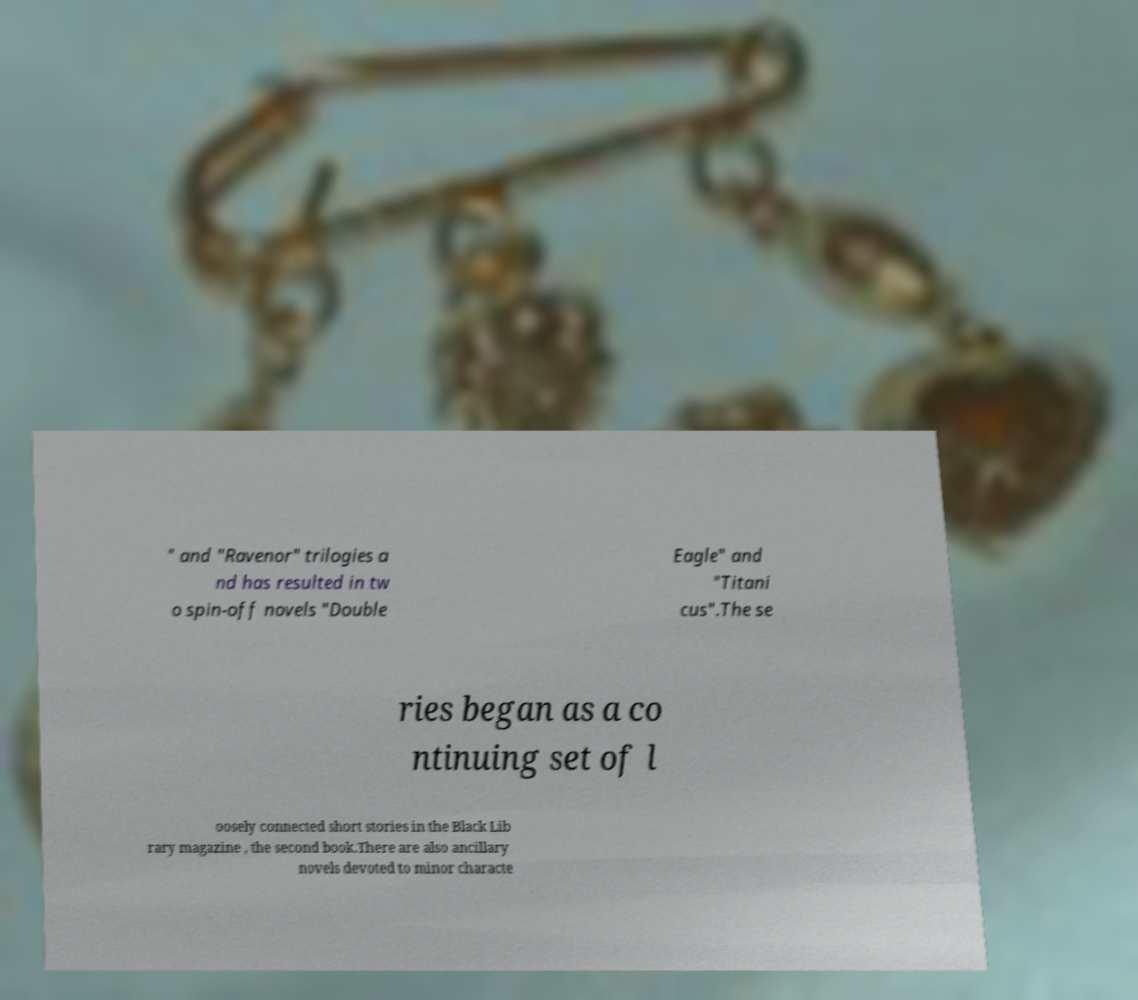What messages or text are displayed in this image? I need them in a readable, typed format. " and "Ravenor" trilogies a nd has resulted in tw o spin-off novels "Double Eagle" and "Titani cus".The se ries began as a co ntinuing set of l oosely connected short stories in the Black Lib rary magazine , the second book.There are also ancillary novels devoted to minor characte 